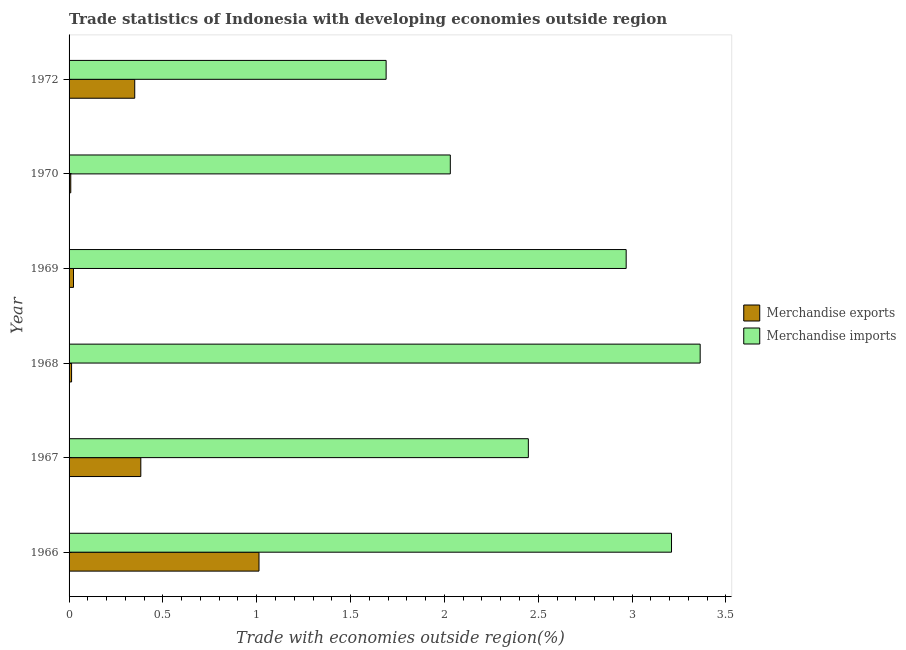How many different coloured bars are there?
Ensure brevity in your answer.  2. How many groups of bars are there?
Your response must be concise. 6. Are the number of bars per tick equal to the number of legend labels?
Provide a short and direct response. Yes. What is the label of the 4th group of bars from the top?
Your answer should be compact. 1968. In how many cases, is the number of bars for a given year not equal to the number of legend labels?
Keep it short and to the point. 0. What is the merchandise exports in 1969?
Offer a terse response. 0.02. Across all years, what is the maximum merchandise imports?
Your response must be concise. 3.36. Across all years, what is the minimum merchandise exports?
Give a very brief answer. 0.01. In which year was the merchandise exports maximum?
Your answer should be compact. 1966. In which year was the merchandise imports minimum?
Offer a very short reply. 1972. What is the total merchandise exports in the graph?
Keep it short and to the point. 1.79. What is the difference between the merchandise exports in 1967 and that in 1968?
Your response must be concise. 0.37. What is the difference between the merchandise exports in 1968 and the merchandise imports in 1970?
Ensure brevity in your answer.  -2.02. What is the average merchandise exports per year?
Offer a very short reply. 0.3. In the year 1968, what is the difference between the merchandise imports and merchandise exports?
Provide a succinct answer. 3.35. In how many years, is the merchandise imports greater than 2.3 %?
Give a very brief answer. 4. What is the ratio of the merchandise imports in 1966 to that in 1969?
Provide a short and direct response. 1.08. Is the merchandise imports in 1969 less than that in 1970?
Your answer should be compact. No. Is the difference between the merchandise imports in 1967 and 1968 greater than the difference between the merchandise exports in 1967 and 1968?
Offer a very short reply. No. What is the difference between the highest and the second highest merchandise imports?
Your response must be concise. 0.15. What is the difference between the highest and the lowest merchandise imports?
Offer a very short reply. 1.67. In how many years, is the merchandise exports greater than the average merchandise exports taken over all years?
Make the answer very short. 3. Is the sum of the merchandise exports in 1966 and 1969 greater than the maximum merchandise imports across all years?
Offer a terse response. No. What does the 1st bar from the top in 1969 represents?
Your answer should be very brief. Merchandise imports. What does the 1st bar from the bottom in 1970 represents?
Your answer should be very brief. Merchandise exports. How many bars are there?
Offer a terse response. 12. Does the graph contain any zero values?
Offer a very short reply. No. Does the graph contain grids?
Ensure brevity in your answer.  No. Where does the legend appear in the graph?
Provide a succinct answer. Center right. How are the legend labels stacked?
Keep it short and to the point. Vertical. What is the title of the graph?
Your answer should be compact. Trade statistics of Indonesia with developing economies outside region. Does "Agricultural land" appear as one of the legend labels in the graph?
Provide a short and direct response. No. What is the label or title of the X-axis?
Provide a succinct answer. Trade with economies outside region(%). What is the Trade with economies outside region(%) of Merchandise exports in 1966?
Offer a terse response. 1.01. What is the Trade with economies outside region(%) in Merchandise imports in 1966?
Offer a very short reply. 3.21. What is the Trade with economies outside region(%) in Merchandise exports in 1967?
Make the answer very short. 0.38. What is the Trade with economies outside region(%) in Merchandise imports in 1967?
Provide a short and direct response. 2.45. What is the Trade with economies outside region(%) in Merchandise exports in 1968?
Keep it short and to the point. 0.01. What is the Trade with economies outside region(%) in Merchandise imports in 1968?
Provide a succinct answer. 3.36. What is the Trade with economies outside region(%) of Merchandise exports in 1969?
Your answer should be compact. 0.02. What is the Trade with economies outside region(%) of Merchandise imports in 1969?
Offer a very short reply. 2.97. What is the Trade with economies outside region(%) in Merchandise exports in 1970?
Make the answer very short. 0.01. What is the Trade with economies outside region(%) in Merchandise imports in 1970?
Your answer should be compact. 2.03. What is the Trade with economies outside region(%) of Merchandise exports in 1972?
Ensure brevity in your answer.  0.35. What is the Trade with economies outside region(%) in Merchandise imports in 1972?
Give a very brief answer. 1.69. Across all years, what is the maximum Trade with economies outside region(%) in Merchandise exports?
Provide a succinct answer. 1.01. Across all years, what is the maximum Trade with economies outside region(%) of Merchandise imports?
Offer a terse response. 3.36. Across all years, what is the minimum Trade with economies outside region(%) of Merchandise exports?
Ensure brevity in your answer.  0.01. Across all years, what is the minimum Trade with economies outside region(%) in Merchandise imports?
Provide a short and direct response. 1.69. What is the total Trade with economies outside region(%) of Merchandise exports in the graph?
Your answer should be compact. 1.79. What is the total Trade with economies outside region(%) in Merchandise imports in the graph?
Your answer should be very brief. 15.71. What is the difference between the Trade with economies outside region(%) of Merchandise exports in 1966 and that in 1967?
Provide a short and direct response. 0.63. What is the difference between the Trade with economies outside region(%) in Merchandise imports in 1966 and that in 1967?
Offer a very short reply. 0.76. What is the difference between the Trade with economies outside region(%) in Merchandise imports in 1966 and that in 1968?
Offer a very short reply. -0.15. What is the difference between the Trade with economies outside region(%) in Merchandise exports in 1966 and that in 1969?
Provide a succinct answer. 0.99. What is the difference between the Trade with economies outside region(%) in Merchandise imports in 1966 and that in 1969?
Keep it short and to the point. 0.24. What is the difference between the Trade with economies outside region(%) of Merchandise exports in 1966 and that in 1970?
Offer a terse response. 1. What is the difference between the Trade with economies outside region(%) of Merchandise imports in 1966 and that in 1970?
Give a very brief answer. 1.18. What is the difference between the Trade with economies outside region(%) of Merchandise exports in 1966 and that in 1972?
Provide a short and direct response. 0.66. What is the difference between the Trade with economies outside region(%) in Merchandise imports in 1966 and that in 1972?
Your answer should be very brief. 1.52. What is the difference between the Trade with economies outside region(%) in Merchandise exports in 1967 and that in 1968?
Offer a terse response. 0.37. What is the difference between the Trade with economies outside region(%) of Merchandise imports in 1967 and that in 1968?
Give a very brief answer. -0.92. What is the difference between the Trade with economies outside region(%) of Merchandise exports in 1967 and that in 1969?
Offer a very short reply. 0.36. What is the difference between the Trade with economies outside region(%) of Merchandise imports in 1967 and that in 1969?
Provide a succinct answer. -0.52. What is the difference between the Trade with economies outside region(%) of Merchandise exports in 1967 and that in 1970?
Your answer should be compact. 0.37. What is the difference between the Trade with economies outside region(%) in Merchandise imports in 1967 and that in 1970?
Keep it short and to the point. 0.42. What is the difference between the Trade with economies outside region(%) in Merchandise exports in 1967 and that in 1972?
Ensure brevity in your answer.  0.03. What is the difference between the Trade with economies outside region(%) of Merchandise imports in 1967 and that in 1972?
Ensure brevity in your answer.  0.76. What is the difference between the Trade with economies outside region(%) of Merchandise exports in 1968 and that in 1969?
Your response must be concise. -0.01. What is the difference between the Trade with economies outside region(%) in Merchandise imports in 1968 and that in 1969?
Provide a succinct answer. 0.39. What is the difference between the Trade with economies outside region(%) in Merchandise exports in 1968 and that in 1970?
Give a very brief answer. 0. What is the difference between the Trade with economies outside region(%) in Merchandise imports in 1968 and that in 1970?
Your answer should be compact. 1.33. What is the difference between the Trade with economies outside region(%) in Merchandise exports in 1968 and that in 1972?
Make the answer very short. -0.34. What is the difference between the Trade with economies outside region(%) of Merchandise imports in 1968 and that in 1972?
Offer a very short reply. 1.67. What is the difference between the Trade with economies outside region(%) in Merchandise exports in 1969 and that in 1970?
Your answer should be very brief. 0.01. What is the difference between the Trade with economies outside region(%) of Merchandise imports in 1969 and that in 1970?
Your answer should be very brief. 0.94. What is the difference between the Trade with economies outside region(%) in Merchandise exports in 1969 and that in 1972?
Your answer should be very brief. -0.33. What is the difference between the Trade with economies outside region(%) in Merchandise imports in 1969 and that in 1972?
Provide a succinct answer. 1.28. What is the difference between the Trade with economies outside region(%) of Merchandise exports in 1970 and that in 1972?
Your answer should be compact. -0.34. What is the difference between the Trade with economies outside region(%) in Merchandise imports in 1970 and that in 1972?
Keep it short and to the point. 0.34. What is the difference between the Trade with economies outside region(%) of Merchandise exports in 1966 and the Trade with economies outside region(%) of Merchandise imports in 1967?
Provide a succinct answer. -1.44. What is the difference between the Trade with economies outside region(%) in Merchandise exports in 1966 and the Trade with economies outside region(%) in Merchandise imports in 1968?
Keep it short and to the point. -2.35. What is the difference between the Trade with economies outside region(%) of Merchandise exports in 1966 and the Trade with economies outside region(%) of Merchandise imports in 1969?
Give a very brief answer. -1.96. What is the difference between the Trade with economies outside region(%) in Merchandise exports in 1966 and the Trade with economies outside region(%) in Merchandise imports in 1970?
Your response must be concise. -1.02. What is the difference between the Trade with economies outside region(%) of Merchandise exports in 1966 and the Trade with economies outside region(%) of Merchandise imports in 1972?
Offer a very short reply. -0.68. What is the difference between the Trade with economies outside region(%) in Merchandise exports in 1967 and the Trade with economies outside region(%) in Merchandise imports in 1968?
Provide a succinct answer. -2.98. What is the difference between the Trade with economies outside region(%) of Merchandise exports in 1967 and the Trade with economies outside region(%) of Merchandise imports in 1969?
Ensure brevity in your answer.  -2.59. What is the difference between the Trade with economies outside region(%) of Merchandise exports in 1967 and the Trade with economies outside region(%) of Merchandise imports in 1970?
Provide a short and direct response. -1.65. What is the difference between the Trade with economies outside region(%) in Merchandise exports in 1967 and the Trade with economies outside region(%) in Merchandise imports in 1972?
Give a very brief answer. -1.31. What is the difference between the Trade with economies outside region(%) of Merchandise exports in 1968 and the Trade with economies outside region(%) of Merchandise imports in 1969?
Ensure brevity in your answer.  -2.95. What is the difference between the Trade with economies outside region(%) of Merchandise exports in 1968 and the Trade with economies outside region(%) of Merchandise imports in 1970?
Keep it short and to the point. -2.02. What is the difference between the Trade with economies outside region(%) of Merchandise exports in 1968 and the Trade with economies outside region(%) of Merchandise imports in 1972?
Your answer should be very brief. -1.68. What is the difference between the Trade with economies outside region(%) of Merchandise exports in 1969 and the Trade with economies outside region(%) of Merchandise imports in 1970?
Your response must be concise. -2.01. What is the difference between the Trade with economies outside region(%) of Merchandise exports in 1969 and the Trade with economies outside region(%) of Merchandise imports in 1972?
Provide a succinct answer. -1.67. What is the difference between the Trade with economies outside region(%) in Merchandise exports in 1970 and the Trade with economies outside region(%) in Merchandise imports in 1972?
Give a very brief answer. -1.68. What is the average Trade with economies outside region(%) in Merchandise exports per year?
Your answer should be very brief. 0.3. What is the average Trade with economies outside region(%) in Merchandise imports per year?
Your answer should be very brief. 2.62. In the year 1966, what is the difference between the Trade with economies outside region(%) in Merchandise exports and Trade with economies outside region(%) in Merchandise imports?
Provide a short and direct response. -2.2. In the year 1967, what is the difference between the Trade with economies outside region(%) in Merchandise exports and Trade with economies outside region(%) in Merchandise imports?
Ensure brevity in your answer.  -2.06. In the year 1968, what is the difference between the Trade with economies outside region(%) of Merchandise exports and Trade with economies outside region(%) of Merchandise imports?
Your response must be concise. -3.35. In the year 1969, what is the difference between the Trade with economies outside region(%) in Merchandise exports and Trade with economies outside region(%) in Merchandise imports?
Provide a succinct answer. -2.94. In the year 1970, what is the difference between the Trade with economies outside region(%) in Merchandise exports and Trade with economies outside region(%) in Merchandise imports?
Your answer should be compact. -2.02. In the year 1972, what is the difference between the Trade with economies outside region(%) in Merchandise exports and Trade with economies outside region(%) in Merchandise imports?
Ensure brevity in your answer.  -1.34. What is the ratio of the Trade with economies outside region(%) in Merchandise exports in 1966 to that in 1967?
Ensure brevity in your answer.  2.65. What is the ratio of the Trade with economies outside region(%) in Merchandise imports in 1966 to that in 1967?
Your response must be concise. 1.31. What is the ratio of the Trade with economies outside region(%) in Merchandise exports in 1966 to that in 1968?
Offer a terse response. 75.59. What is the ratio of the Trade with economies outside region(%) of Merchandise imports in 1966 to that in 1968?
Provide a succinct answer. 0.95. What is the ratio of the Trade with economies outside region(%) of Merchandise exports in 1966 to that in 1969?
Your response must be concise. 42.91. What is the ratio of the Trade with economies outside region(%) in Merchandise imports in 1966 to that in 1969?
Your response must be concise. 1.08. What is the ratio of the Trade with economies outside region(%) of Merchandise exports in 1966 to that in 1970?
Your response must be concise. 111.91. What is the ratio of the Trade with economies outside region(%) of Merchandise imports in 1966 to that in 1970?
Offer a terse response. 1.58. What is the ratio of the Trade with economies outside region(%) in Merchandise exports in 1966 to that in 1972?
Keep it short and to the point. 2.89. What is the ratio of the Trade with economies outside region(%) of Merchandise imports in 1966 to that in 1972?
Offer a terse response. 1.9. What is the ratio of the Trade with economies outside region(%) in Merchandise exports in 1967 to that in 1968?
Your response must be concise. 28.55. What is the ratio of the Trade with economies outside region(%) of Merchandise imports in 1967 to that in 1968?
Your answer should be very brief. 0.73. What is the ratio of the Trade with economies outside region(%) of Merchandise exports in 1967 to that in 1969?
Provide a short and direct response. 16.21. What is the ratio of the Trade with economies outside region(%) of Merchandise imports in 1967 to that in 1969?
Keep it short and to the point. 0.82. What is the ratio of the Trade with economies outside region(%) of Merchandise exports in 1967 to that in 1970?
Make the answer very short. 42.27. What is the ratio of the Trade with economies outside region(%) in Merchandise imports in 1967 to that in 1970?
Your answer should be compact. 1.2. What is the ratio of the Trade with economies outside region(%) in Merchandise exports in 1967 to that in 1972?
Make the answer very short. 1.09. What is the ratio of the Trade with economies outside region(%) of Merchandise imports in 1967 to that in 1972?
Offer a terse response. 1.45. What is the ratio of the Trade with economies outside region(%) of Merchandise exports in 1968 to that in 1969?
Keep it short and to the point. 0.57. What is the ratio of the Trade with economies outside region(%) of Merchandise imports in 1968 to that in 1969?
Offer a very short reply. 1.13. What is the ratio of the Trade with economies outside region(%) of Merchandise exports in 1968 to that in 1970?
Provide a short and direct response. 1.48. What is the ratio of the Trade with economies outside region(%) of Merchandise imports in 1968 to that in 1970?
Offer a very short reply. 1.66. What is the ratio of the Trade with economies outside region(%) in Merchandise exports in 1968 to that in 1972?
Provide a short and direct response. 0.04. What is the ratio of the Trade with economies outside region(%) of Merchandise imports in 1968 to that in 1972?
Offer a terse response. 1.99. What is the ratio of the Trade with economies outside region(%) in Merchandise exports in 1969 to that in 1970?
Your answer should be very brief. 2.61. What is the ratio of the Trade with economies outside region(%) in Merchandise imports in 1969 to that in 1970?
Offer a terse response. 1.46. What is the ratio of the Trade with economies outside region(%) in Merchandise exports in 1969 to that in 1972?
Your answer should be compact. 0.07. What is the ratio of the Trade with economies outside region(%) in Merchandise imports in 1969 to that in 1972?
Give a very brief answer. 1.76. What is the ratio of the Trade with economies outside region(%) in Merchandise exports in 1970 to that in 1972?
Offer a terse response. 0.03. What is the ratio of the Trade with economies outside region(%) in Merchandise imports in 1970 to that in 1972?
Your response must be concise. 1.2. What is the difference between the highest and the second highest Trade with economies outside region(%) in Merchandise exports?
Offer a very short reply. 0.63. What is the difference between the highest and the second highest Trade with economies outside region(%) in Merchandise imports?
Your answer should be very brief. 0.15. What is the difference between the highest and the lowest Trade with economies outside region(%) in Merchandise exports?
Your response must be concise. 1. What is the difference between the highest and the lowest Trade with economies outside region(%) of Merchandise imports?
Ensure brevity in your answer.  1.67. 